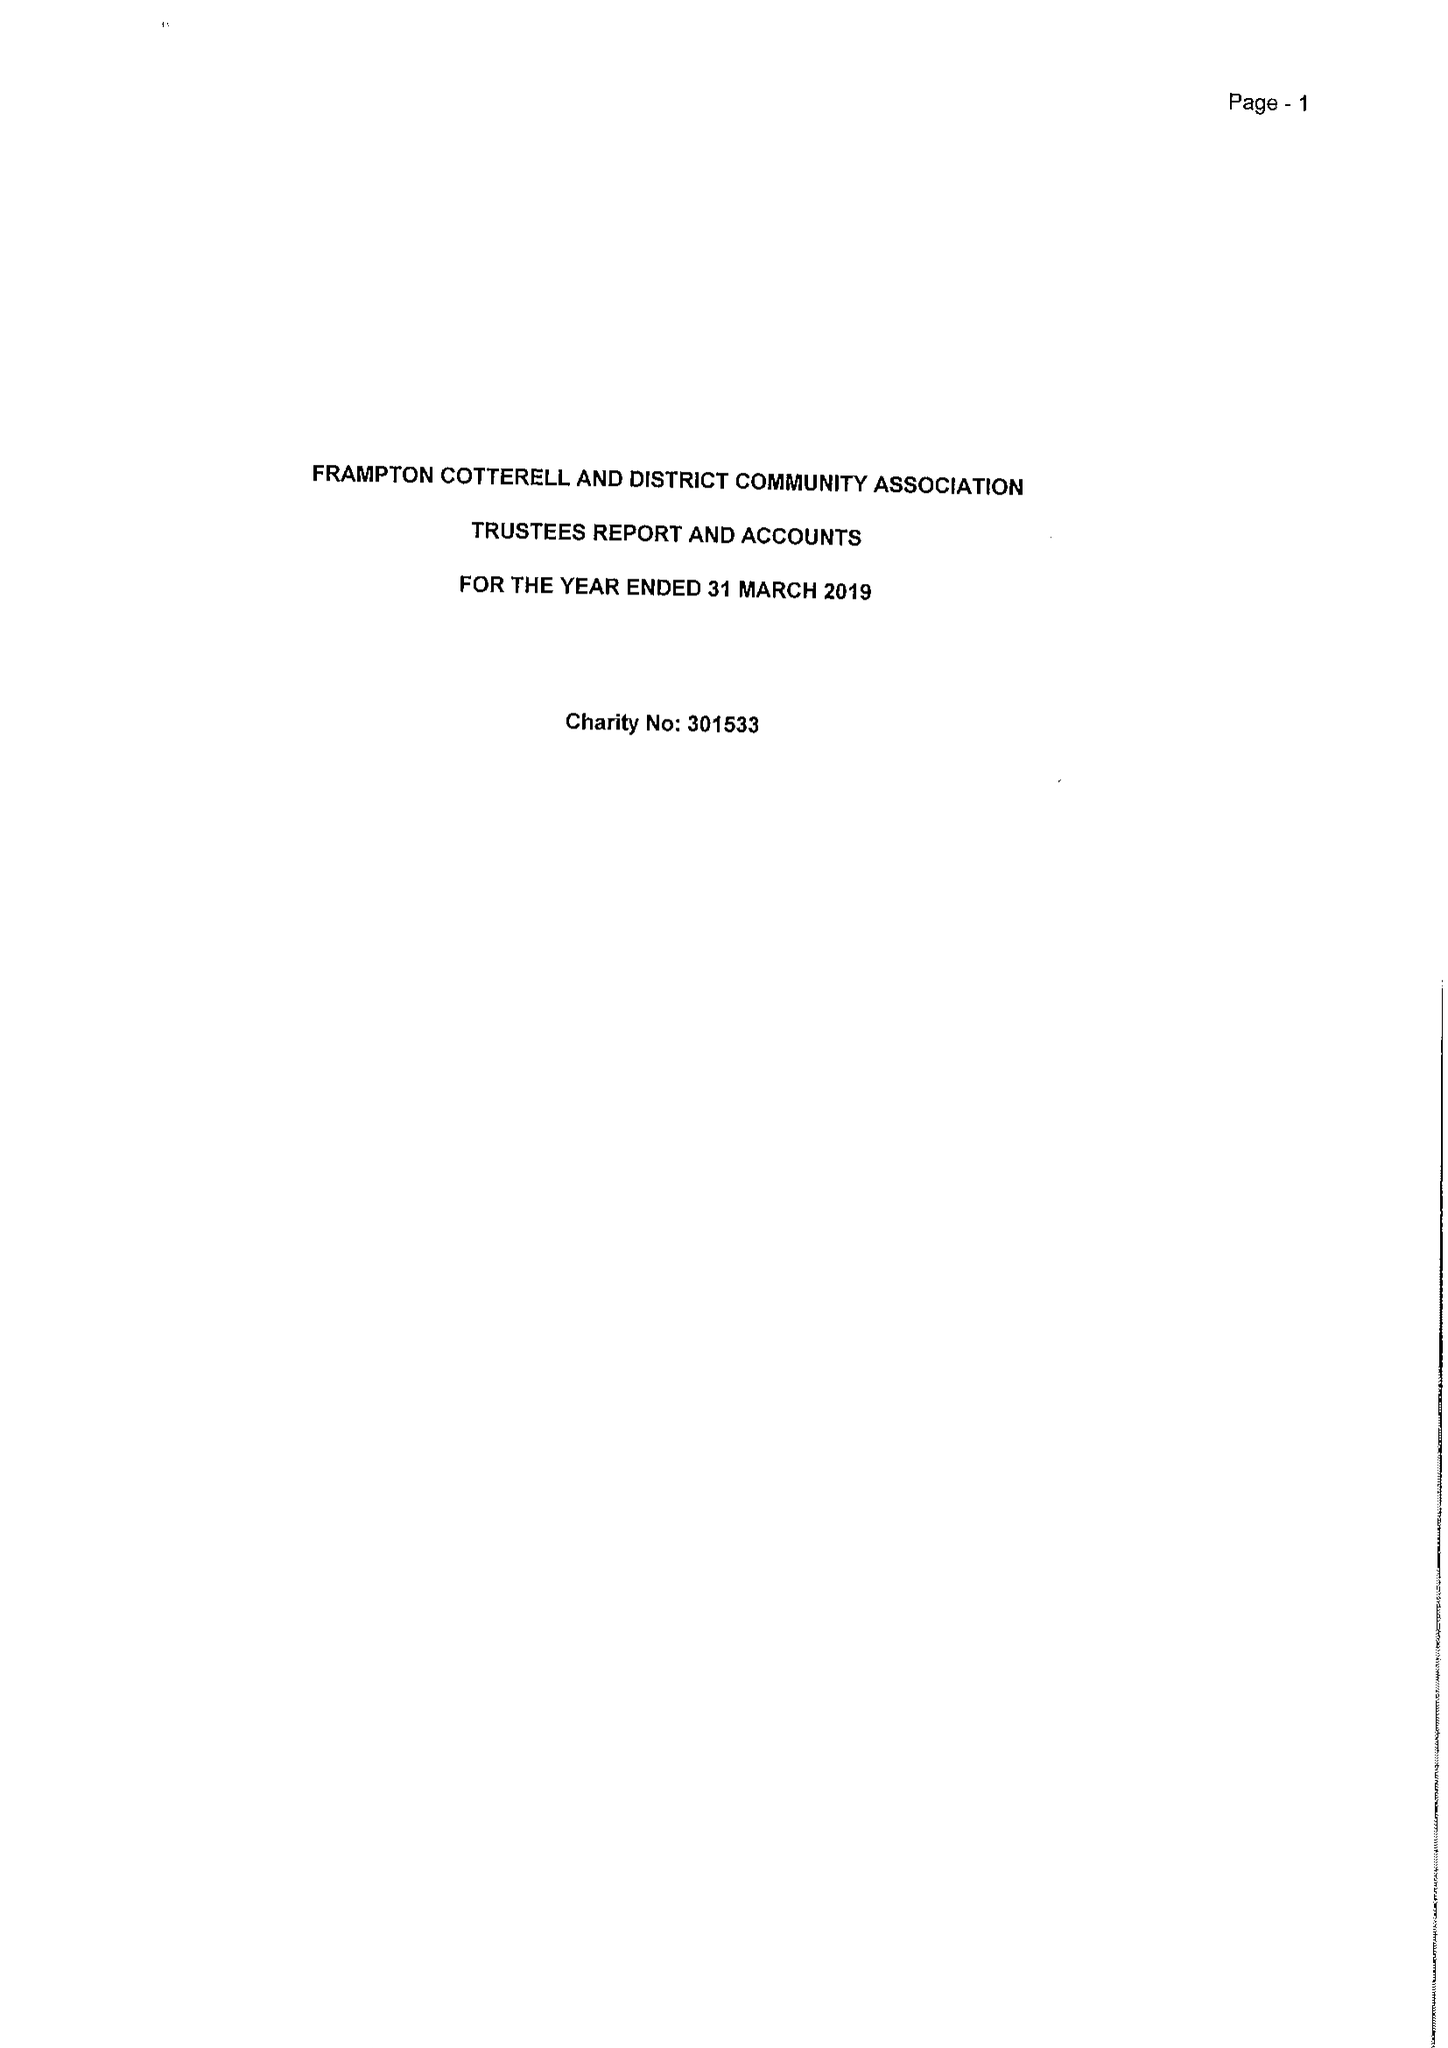What is the value for the charity_name?
Answer the question using a single word or phrase. Frampton Cotterell and District Community Association 